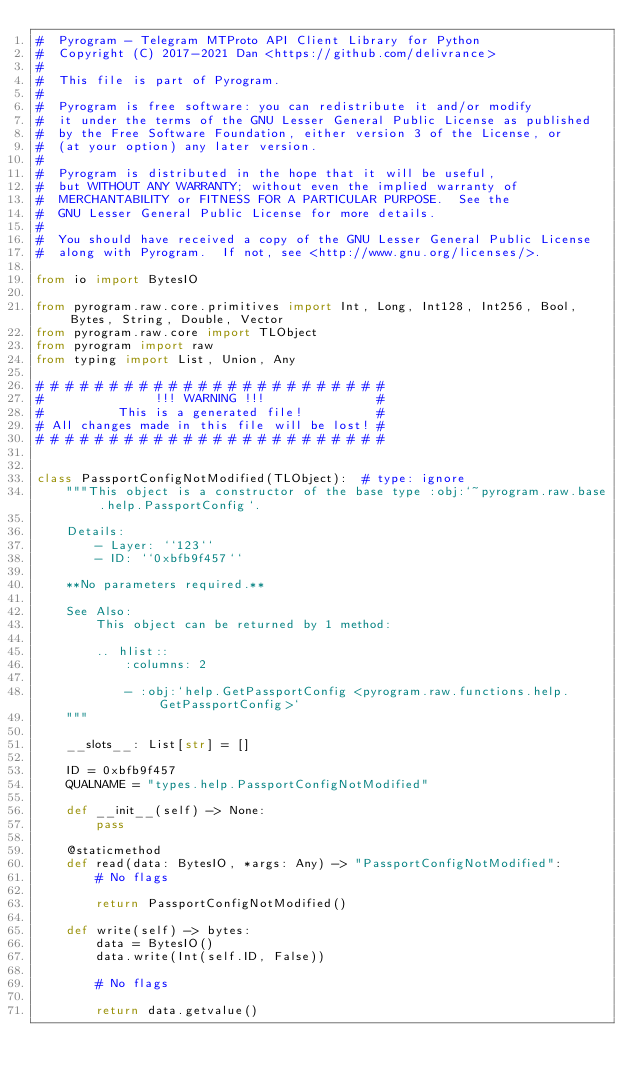Convert code to text. <code><loc_0><loc_0><loc_500><loc_500><_Python_>#  Pyrogram - Telegram MTProto API Client Library for Python
#  Copyright (C) 2017-2021 Dan <https://github.com/delivrance>
#
#  This file is part of Pyrogram.
#
#  Pyrogram is free software: you can redistribute it and/or modify
#  it under the terms of the GNU Lesser General Public License as published
#  by the Free Software Foundation, either version 3 of the License, or
#  (at your option) any later version.
#
#  Pyrogram is distributed in the hope that it will be useful,
#  but WITHOUT ANY WARRANTY; without even the implied warranty of
#  MERCHANTABILITY or FITNESS FOR A PARTICULAR PURPOSE.  See the
#  GNU Lesser General Public License for more details.
#
#  You should have received a copy of the GNU Lesser General Public License
#  along with Pyrogram.  If not, see <http://www.gnu.org/licenses/>.

from io import BytesIO

from pyrogram.raw.core.primitives import Int, Long, Int128, Int256, Bool, Bytes, String, Double, Vector
from pyrogram.raw.core import TLObject
from pyrogram import raw
from typing import List, Union, Any

# # # # # # # # # # # # # # # # # # # # # # # #
#               !!! WARNING !!!               #
#          This is a generated file!          #
# All changes made in this file will be lost! #
# # # # # # # # # # # # # # # # # # # # # # # #


class PassportConfigNotModified(TLObject):  # type: ignore
    """This object is a constructor of the base type :obj:`~pyrogram.raw.base.help.PassportConfig`.

    Details:
        - Layer: ``123``
        - ID: ``0xbfb9f457``

    **No parameters required.**

    See Also:
        This object can be returned by 1 method:

        .. hlist::
            :columns: 2

            - :obj:`help.GetPassportConfig <pyrogram.raw.functions.help.GetPassportConfig>`
    """

    __slots__: List[str] = []

    ID = 0xbfb9f457
    QUALNAME = "types.help.PassportConfigNotModified"

    def __init__(self) -> None:
        pass

    @staticmethod
    def read(data: BytesIO, *args: Any) -> "PassportConfigNotModified":
        # No flags

        return PassportConfigNotModified()

    def write(self) -> bytes:
        data = BytesIO()
        data.write(Int(self.ID, False))

        # No flags

        return data.getvalue()
</code> 